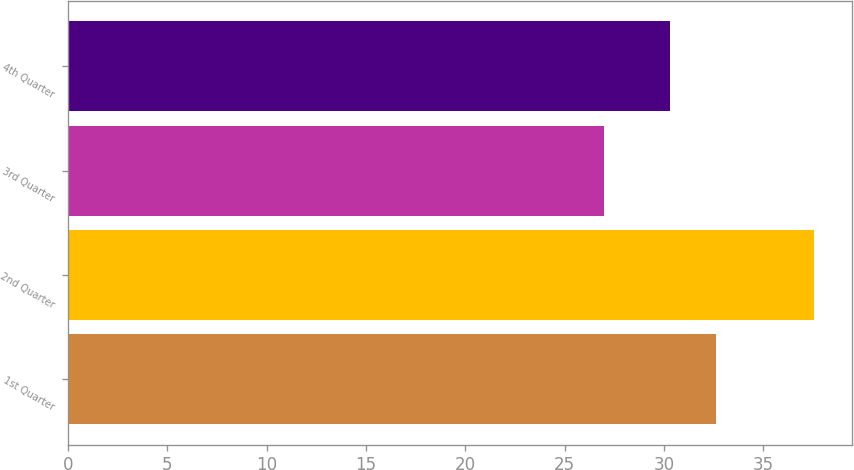Convert chart. <chart><loc_0><loc_0><loc_500><loc_500><bar_chart><fcel>1st Quarter<fcel>2nd Quarter<fcel>3rd Quarter<fcel>4th Quarter<nl><fcel>32.62<fcel>37.56<fcel>27<fcel>30.28<nl></chart> 